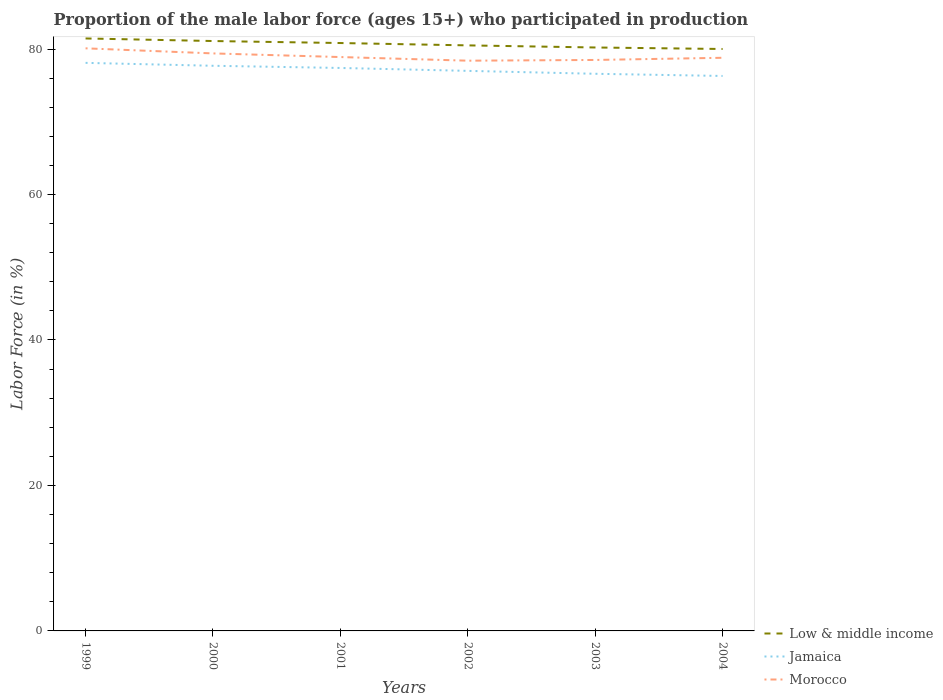Is the number of lines equal to the number of legend labels?
Keep it short and to the point. Yes. Across all years, what is the maximum proportion of the male labor force who participated in production in Low & middle income?
Your answer should be compact. 80.01. What is the total proportion of the male labor force who participated in production in Jamaica in the graph?
Your response must be concise. 0.3. What is the difference between the highest and the second highest proportion of the male labor force who participated in production in Jamaica?
Your answer should be very brief. 1.8. What is the difference between the highest and the lowest proportion of the male labor force who participated in production in Jamaica?
Your response must be concise. 3. Is the proportion of the male labor force who participated in production in Low & middle income strictly greater than the proportion of the male labor force who participated in production in Morocco over the years?
Your answer should be compact. No. How many lines are there?
Keep it short and to the point. 3. How many years are there in the graph?
Your answer should be compact. 6. Does the graph contain grids?
Your answer should be very brief. No. Where does the legend appear in the graph?
Your response must be concise. Bottom right. How are the legend labels stacked?
Offer a terse response. Vertical. What is the title of the graph?
Offer a terse response. Proportion of the male labor force (ages 15+) who participated in production. Does "Turks and Caicos Islands" appear as one of the legend labels in the graph?
Provide a short and direct response. No. What is the label or title of the Y-axis?
Your answer should be very brief. Labor Force (in %). What is the Labor Force (in %) of Low & middle income in 1999?
Ensure brevity in your answer.  81.46. What is the Labor Force (in %) in Jamaica in 1999?
Provide a succinct answer. 78.1. What is the Labor Force (in %) in Morocco in 1999?
Keep it short and to the point. 80.1. What is the Labor Force (in %) of Low & middle income in 2000?
Your response must be concise. 81.1. What is the Labor Force (in %) of Jamaica in 2000?
Provide a succinct answer. 77.7. What is the Labor Force (in %) of Morocco in 2000?
Make the answer very short. 79.4. What is the Labor Force (in %) in Low & middle income in 2001?
Your answer should be very brief. 80.83. What is the Labor Force (in %) of Jamaica in 2001?
Your answer should be compact. 77.4. What is the Labor Force (in %) of Morocco in 2001?
Your answer should be compact. 78.9. What is the Labor Force (in %) of Low & middle income in 2002?
Your response must be concise. 80.5. What is the Labor Force (in %) of Morocco in 2002?
Offer a terse response. 78.4. What is the Labor Force (in %) of Low & middle income in 2003?
Provide a short and direct response. 80.21. What is the Labor Force (in %) in Jamaica in 2003?
Offer a terse response. 76.6. What is the Labor Force (in %) in Morocco in 2003?
Make the answer very short. 78.5. What is the Labor Force (in %) of Low & middle income in 2004?
Provide a short and direct response. 80.01. What is the Labor Force (in %) of Jamaica in 2004?
Your answer should be very brief. 76.3. What is the Labor Force (in %) of Morocco in 2004?
Give a very brief answer. 78.8. Across all years, what is the maximum Labor Force (in %) in Low & middle income?
Give a very brief answer. 81.46. Across all years, what is the maximum Labor Force (in %) in Jamaica?
Your answer should be compact. 78.1. Across all years, what is the maximum Labor Force (in %) of Morocco?
Ensure brevity in your answer.  80.1. Across all years, what is the minimum Labor Force (in %) of Low & middle income?
Provide a succinct answer. 80.01. Across all years, what is the minimum Labor Force (in %) in Jamaica?
Your answer should be compact. 76.3. Across all years, what is the minimum Labor Force (in %) of Morocco?
Your response must be concise. 78.4. What is the total Labor Force (in %) in Low & middle income in the graph?
Give a very brief answer. 484.11. What is the total Labor Force (in %) of Jamaica in the graph?
Your response must be concise. 463.1. What is the total Labor Force (in %) in Morocco in the graph?
Provide a succinct answer. 474.1. What is the difference between the Labor Force (in %) of Low & middle income in 1999 and that in 2000?
Keep it short and to the point. 0.35. What is the difference between the Labor Force (in %) in Morocco in 1999 and that in 2000?
Your response must be concise. 0.7. What is the difference between the Labor Force (in %) in Low & middle income in 1999 and that in 2001?
Offer a very short reply. 0.63. What is the difference between the Labor Force (in %) in Jamaica in 1999 and that in 2001?
Ensure brevity in your answer.  0.7. What is the difference between the Labor Force (in %) of Morocco in 1999 and that in 2001?
Ensure brevity in your answer.  1.2. What is the difference between the Labor Force (in %) of Low & middle income in 1999 and that in 2002?
Provide a succinct answer. 0.95. What is the difference between the Labor Force (in %) of Jamaica in 1999 and that in 2002?
Give a very brief answer. 1.1. What is the difference between the Labor Force (in %) in Low & middle income in 1999 and that in 2003?
Your answer should be compact. 1.24. What is the difference between the Labor Force (in %) of Low & middle income in 1999 and that in 2004?
Your answer should be very brief. 1.45. What is the difference between the Labor Force (in %) of Low & middle income in 2000 and that in 2001?
Offer a terse response. 0.28. What is the difference between the Labor Force (in %) in Jamaica in 2000 and that in 2001?
Make the answer very short. 0.3. What is the difference between the Labor Force (in %) of Morocco in 2000 and that in 2001?
Provide a short and direct response. 0.5. What is the difference between the Labor Force (in %) in Low & middle income in 2000 and that in 2002?
Offer a very short reply. 0.6. What is the difference between the Labor Force (in %) of Low & middle income in 2000 and that in 2003?
Offer a very short reply. 0.89. What is the difference between the Labor Force (in %) in Morocco in 2000 and that in 2003?
Provide a short and direct response. 0.9. What is the difference between the Labor Force (in %) in Low & middle income in 2000 and that in 2004?
Provide a succinct answer. 1.09. What is the difference between the Labor Force (in %) in Jamaica in 2000 and that in 2004?
Your answer should be very brief. 1.4. What is the difference between the Labor Force (in %) in Low & middle income in 2001 and that in 2002?
Offer a very short reply. 0.32. What is the difference between the Labor Force (in %) in Morocco in 2001 and that in 2002?
Provide a short and direct response. 0.5. What is the difference between the Labor Force (in %) of Low & middle income in 2001 and that in 2003?
Your answer should be compact. 0.61. What is the difference between the Labor Force (in %) in Jamaica in 2001 and that in 2003?
Your response must be concise. 0.8. What is the difference between the Labor Force (in %) of Low & middle income in 2001 and that in 2004?
Make the answer very short. 0.82. What is the difference between the Labor Force (in %) in Morocco in 2001 and that in 2004?
Offer a very short reply. 0.1. What is the difference between the Labor Force (in %) in Low & middle income in 2002 and that in 2003?
Provide a succinct answer. 0.29. What is the difference between the Labor Force (in %) of Jamaica in 2002 and that in 2003?
Give a very brief answer. 0.4. What is the difference between the Labor Force (in %) of Morocco in 2002 and that in 2003?
Give a very brief answer. -0.1. What is the difference between the Labor Force (in %) of Low & middle income in 2002 and that in 2004?
Make the answer very short. 0.5. What is the difference between the Labor Force (in %) of Jamaica in 2002 and that in 2004?
Give a very brief answer. 0.7. What is the difference between the Labor Force (in %) of Low & middle income in 2003 and that in 2004?
Your response must be concise. 0.21. What is the difference between the Labor Force (in %) of Jamaica in 2003 and that in 2004?
Your answer should be very brief. 0.3. What is the difference between the Labor Force (in %) of Low & middle income in 1999 and the Labor Force (in %) of Jamaica in 2000?
Keep it short and to the point. 3.76. What is the difference between the Labor Force (in %) in Low & middle income in 1999 and the Labor Force (in %) in Morocco in 2000?
Make the answer very short. 2.06. What is the difference between the Labor Force (in %) in Low & middle income in 1999 and the Labor Force (in %) in Jamaica in 2001?
Your answer should be compact. 4.06. What is the difference between the Labor Force (in %) in Low & middle income in 1999 and the Labor Force (in %) in Morocco in 2001?
Your answer should be compact. 2.56. What is the difference between the Labor Force (in %) in Low & middle income in 1999 and the Labor Force (in %) in Jamaica in 2002?
Offer a terse response. 4.46. What is the difference between the Labor Force (in %) in Low & middle income in 1999 and the Labor Force (in %) in Morocco in 2002?
Keep it short and to the point. 3.06. What is the difference between the Labor Force (in %) in Low & middle income in 1999 and the Labor Force (in %) in Jamaica in 2003?
Provide a succinct answer. 4.86. What is the difference between the Labor Force (in %) in Low & middle income in 1999 and the Labor Force (in %) in Morocco in 2003?
Give a very brief answer. 2.96. What is the difference between the Labor Force (in %) of Low & middle income in 1999 and the Labor Force (in %) of Jamaica in 2004?
Ensure brevity in your answer.  5.16. What is the difference between the Labor Force (in %) in Low & middle income in 1999 and the Labor Force (in %) in Morocco in 2004?
Keep it short and to the point. 2.66. What is the difference between the Labor Force (in %) of Low & middle income in 2000 and the Labor Force (in %) of Jamaica in 2001?
Your answer should be very brief. 3.7. What is the difference between the Labor Force (in %) of Low & middle income in 2000 and the Labor Force (in %) of Morocco in 2001?
Your answer should be compact. 2.2. What is the difference between the Labor Force (in %) in Low & middle income in 2000 and the Labor Force (in %) in Jamaica in 2002?
Make the answer very short. 4.1. What is the difference between the Labor Force (in %) in Low & middle income in 2000 and the Labor Force (in %) in Morocco in 2002?
Your response must be concise. 2.7. What is the difference between the Labor Force (in %) in Jamaica in 2000 and the Labor Force (in %) in Morocco in 2002?
Provide a succinct answer. -0.7. What is the difference between the Labor Force (in %) in Low & middle income in 2000 and the Labor Force (in %) in Jamaica in 2003?
Provide a short and direct response. 4.5. What is the difference between the Labor Force (in %) of Low & middle income in 2000 and the Labor Force (in %) of Morocco in 2003?
Keep it short and to the point. 2.6. What is the difference between the Labor Force (in %) in Jamaica in 2000 and the Labor Force (in %) in Morocco in 2003?
Make the answer very short. -0.8. What is the difference between the Labor Force (in %) in Low & middle income in 2000 and the Labor Force (in %) in Jamaica in 2004?
Keep it short and to the point. 4.8. What is the difference between the Labor Force (in %) in Low & middle income in 2000 and the Labor Force (in %) in Morocco in 2004?
Your answer should be compact. 2.3. What is the difference between the Labor Force (in %) of Jamaica in 2000 and the Labor Force (in %) of Morocco in 2004?
Your answer should be very brief. -1.1. What is the difference between the Labor Force (in %) in Low & middle income in 2001 and the Labor Force (in %) in Jamaica in 2002?
Offer a terse response. 3.83. What is the difference between the Labor Force (in %) of Low & middle income in 2001 and the Labor Force (in %) of Morocco in 2002?
Make the answer very short. 2.43. What is the difference between the Labor Force (in %) of Low & middle income in 2001 and the Labor Force (in %) of Jamaica in 2003?
Ensure brevity in your answer.  4.23. What is the difference between the Labor Force (in %) in Low & middle income in 2001 and the Labor Force (in %) in Morocco in 2003?
Provide a succinct answer. 2.33. What is the difference between the Labor Force (in %) in Low & middle income in 2001 and the Labor Force (in %) in Jamaica in 2004?
Offer a very short reply. 4.53. What is the difference between the Labor Force (in %) in Low & middle income in 2001 and the Labor Force (in %) in Morocco in 2004?
Make the answer very short. 2.03. What is the difference between the Labor Force (in %) in Low & middle income in 2002 and the Labor Force (in %) in Jamaica in 2003?
Offer a very short reply. 3.9. What is the difference between the Labor Force (in %) of Low & middle income in 2002 and the Labor Force (in %) of Morocco in 2003?
Offer a terse response. 2. What is the difference between the Labor Force (in %) in Low & middle income in 2002 and the Labor Force (in %) in Jamaica in 2004?
Ensure brevity in your answer.  4.2. What is the difference between the Labor Force (in %) in Low & middle income in 2002 and the Labor Force (in %) in Morocco in 2004?
Offer a terse response. 1.7. What is the difference between the Labor Force (in %) in Low & middle income in 2003 and the Labor Force (in %) in Jamaica in 2004?
Keep it short and to the point. 3.91. What is the difference between the Labor Force (in %) of Low & middle income in 2003 and the Labor Force (in %) of Morocco in 2004?
Keep it short and to the point. 1.41. What is the difference between the Labor Force (in %) in Jamaica in 2003 and the Labor Force (in %) in Morocco in 2004?
Make the answer very short. -2.2. What is the average Labor Force (in %) in Low & middle income per year?
Your response must be concise. 80.69. What is the average Labor Force (in %) in Jamaica per year?
Ensure brevity in your answer.  77.18. What is the average Labor Force (in %) of Morocco per year?
Your answer should be very brief. 79.02. In the year 1999, what is the difference between the Labor Force (in %) in Low & middle income and Labor Force (in %) in Jamaica?
Your answer should be compact. 3.36. In the year 1999, what is the difference between the Labor Force (in %) in Low & middle income and Labor Force (in %) in Morocco?
Your response must be concise. 1.36. In the year 2000, what is the difference between the Labor Force (in %) of Low & middle income and Labor Force (in %) of Jamaica?
Offer a very short reply. 3.4. In the year 2000, what is the difference between the Labor Force (in %) in Low & middle income and Labor Force (in %) in Morocco?
Make the answer very short. 1.7. In the year 2001, what is the difference between the Labor Force (in %) of Low & middle income and Labor Force (in %) of Jamaica?
Make the answer very short. 3.43. In the year 2001, what is the difference between the Labor Force (in %) of Low & middle income and Labor Force (in %) of Morocco?
Your answer should be very brief. 1.93. In the year 2001, what is the difference between the Labor Force (in %) of Jamaica and Labor Force (in %) of Morocco?
Make the answer very short. -1.5. In the year 2002, what is the difference between the Labor Force (in %) in Low & middle income and Labor Force (in %) in Jamaica?
Provide a succinct answer. 3.5. In the year 2002, what is the difference between the Labor Force (in %) in Low & middle income and Labor Force (in %) in Morocco?
Offer a very short reply. 2.1. In the year 2002, what is the difference between the Labor Force (in %) in Jamaica and Labor Force (in %) in Morocco?
Your answer should be very brief. -1.4. In the year 2003, what is the difference between the Labor Force (in %) in Low & middle income and Labor Force (in %) in Jamaica?
Your answer should be compact. 3.61. In the year 2003, what is the difference between the Labor Force (in %) in Low & middle income and Labor Force (in %) in Morocco?
Offer a very short reply. 1.71. In the year 2003, what is the difference between the Labor Force (in %) of Jamaica and Labor Force (in %) of Morocco?
Give a very brief answer. -1.9. In the year 2004, what is the difference between the Labor Force (in %) in Low & middle income and Labor Force (in %) in Jamaica?
Your answer should be very brief. 3.71. In the year 2004, what is the difference between the Labor Force (in %) in Low & middle income and Labor Force (in %) in Morocco?
Give a very brief answer. 1.21. In the year 2004, what is the difference between the Labor Force (in %) of Jamaica and Labor Force (in %) of Morocco?
Your answer should be compact. -2.5. What is the ratio of the Labor Force (in %) in Low & middle income in 1999 to that in 2000?
Offer a very short reply. 1. What is the ratio of the Labor Force (in %) in Jamaica in 1999 to that in 2000?
Your answer should be compact. 1.01. What is the ratio of the Labor Force (in %) in Morocco in 1999 to that in 2000?
Your answer should be compact. 1.01. What is the ratio of the Labor Force (in %) of Morocco in 1999 to that in 2001?
Your answer should be compact. 1.02. What is the ratio of the Labor Force (in %) of Low & middle income in 1999 to that in 2002?
Your answer should be very brief. 1.01. What is the ratio of the Labor Force (in %) in Jamaica in 1999 to that in 2002?
Offer a very short reply. 1.01. What is the ratio of the Labor Force (in %) in Morocco in 1999 to that in 2002?
Give a very brief answer. 1.02. What is the ratio of the Labor Force (in %) of Low & middle income in 1999 to that in 2003?
Give a very brief answer. 1.02. What is the ratio of the Labor Force (in %) in Jamaica in 1999 to that in 2003?
Offer a very short reply. 1.02. What is the ratio of the Labor Force (in %) in Morocco in 1999 to that in 2003?
Your answer should be very brief. 1.02. What is the ratio of the Labor Force (in %) of Low & middle income in 1999 to that in 2004?
Offer a very short reply. 1.02. What is the ratio of the Labor Force (in %) of Jamaica in 1999 to that in 2004?
Provide a succinct answer. 1.02. What is the ratio of the Labor Force (in %) in Morocco in 1999 to that in 2004?
Ensure brevity in your answer.  1.02. What is the ratio of the Labor Force (in %) in Low & middle income in 2000 to that in 2002?
Give a very brief answer. 1.01. What is the ratio of the Labor Force (in %) of Jamaica in 2000 to that in 2002?
Your answer should be compact. 1.01. What is the ratio of the Labor Force (in %) of Morocco in 2000 to that in 2002?
Give a very brief answer. 1.01. What is the ratio of the Labor Force (in %) in Low & middle income in 2000 to that in 2003?
Offer a very short reply. 1.01. What is the ratio of the Labor Force (in %) of Jamaica in 2000 to that in 2003?
Make the answer very short. 1.01. What is the ratio of the Labor Force (in %) in Morocco in 2000 to that in 2003?
Provide a succinct answer. 1.01. What is the ratio of the Labor Force (in %) of Low & middle income in 2000 to that in 2004?
Your answer should be compact. 1.01. What is the ratio of the Labor Force (in %) of Jamaica in 2000 to that in 2004?
Ensure brevity in your answer.  1.02. What is the ratio of the Labor Force (in %) in Morocco in 2000 to that in 2004?
Provide a succinct answer. 1.01. What is the ratio of the Labor Force (in %) in Low & middle income in 2001 to that in 2002?
Your answer should be very brief. 1. What is the ratio of the Labor Force (in %) of Morocco in 2001 to that in 2002?
Provide a short and direct response. 1.01. What is the ratio of the Labor Force (in %) in Low & middle income in 2001 to that in 2003?
Your answer should be compact. 1.01. What is the ratio of the Labor Force (in %) in Jamaica in 2001 to that in 2003?
Make the answer very short. 1.01. What is the ratio of the Labor Force (in %) of Morocco in 2001 to that in 2003?
Offer a terse response. 1.01. What is the ratio of the Labor Force (in %) of Low & middle income in 2001 to that in 2004?
Ensure brevity in your answer.  1.01. What is the ratio of the Labor Force (in %) in Jamaica in 2001 to that in 2004?
Ensure brevity in your answer.  1.01. What is the ratio of the Labor Force (in %) in Low & middle income in 2002 to that in 2003?
Ensure brevity in your answer.  1. What is the ratio of the Labor Force (in %) of Morocco in 2002 to that in 2003?
Provide a succinct answer. 1. What is the ratio of the Labor Force (in %) of Low & middle income in 2002 to that in 2004?
Ensure brevity in your answer.  1.01. What is the ratio of the Labor Force (in %) in Jamaica in 2002 to that in 2004?
Your answer should be compact. 1.01. What is the ratio of the Labor Force (in %) of Morocco in 2002 to that in 2004?
Offer a very short reply. 0.99. What is the ratio of the Labor Force (in %) of Low & middle income in 2003 to that in 2004?
Keep it short and to the point. 1. What is the ratio of the Labor Force (in %) in Jamaica in 2003 to that in 2004?
Make the answer very short. 1. What is the ratio of the Labor Force (in %) of Morocco in 2003 to that in 2004?
Your answer should be compact. 1. What is the difference between the highest and the second highest Labor Force (in %) in Low & middle income?
Your answer should be compact. 0.35. What is the difference between the highest and the lowest Labor Force (in %) of Low & middle income?
Give a very brief answer. 1.45. What is the difference between the highest and the lowest Labor Force (in %) of Morocco?
Provide a succinct answer. 1.7. 